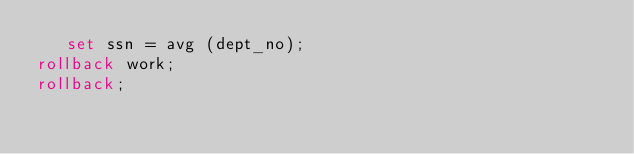Convert code to text. <code><loc_0><loc_0><loc_500><loc_500><_SQL_>   set ssn = avg (dept_no);
rollback work;
rollback;
</code> 